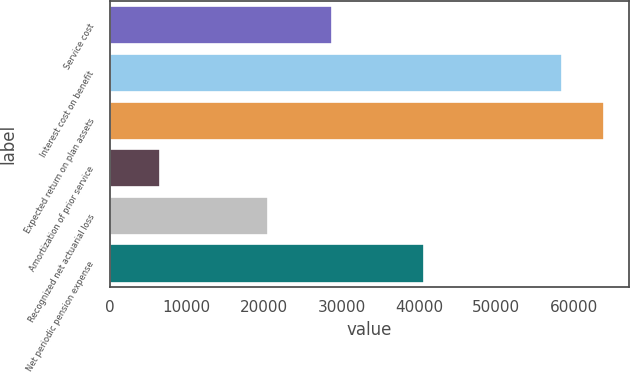Convert chart to OTSL. <chart><loc_0><loc_0><loc_500><loc_500><bar_chart><fcel>Service cost<fcel>Interest cost on benefit<fcel>Expected return on plan assets<fcel>Amortization of prior service<fcel>Recognized net actuarial loss<fcel>Net periodic pension expense<nl><fcel>28828<fcel>58545<fcel>63959.1<fcel>6559<fcel>20530<fcel>40644<nl></chart> 